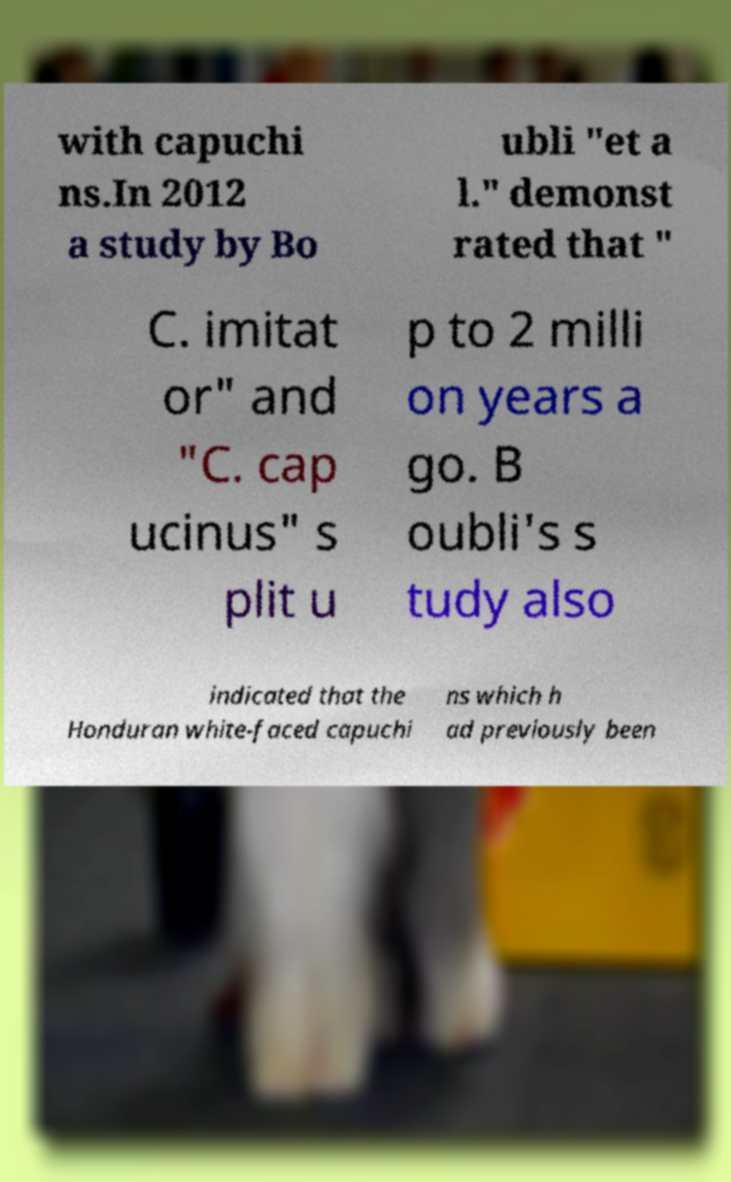For documentation purposes, I need the text within this image transcribed. Could you provide that? with capuchi ns.In 2012 a study by Bo ubli "et a l." demonst rated that " C. imitat or" and "C. cap ucinus" s plit u p to 2 milli on years a go. B oubli's s tudy also indicated that the Honduran white-faced capuchi ns which h ad previously been 